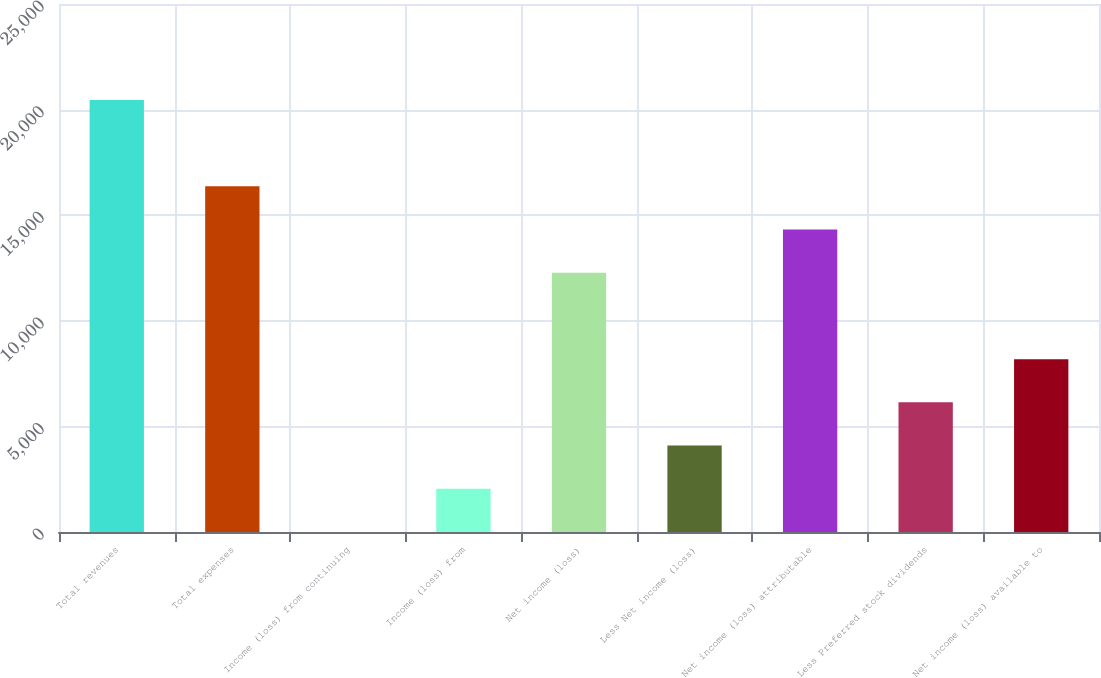Convert chart. <chart><loc_0><loc_0><loc_500><loc_500><bar_chart><fcel>Total revenues<fcel>Total expenses<fcel>Income (loss) from continuing<fcel>Income (loss) from<fcel>Net income (loss)<fcel>Less Net income (loss)<fcel>Net income (loss) attributable<fcel>Less Preferred stock dividends<fcel>Net income (loss) available to<nl><fcel>20457<fcel>16366.3<fcel>3.35<fcel>2048.72<fcel>12275.5<fcel>4094.09<fcel>14320.9<fcel>6139.45<fcel>8184.82<nl></chart> 